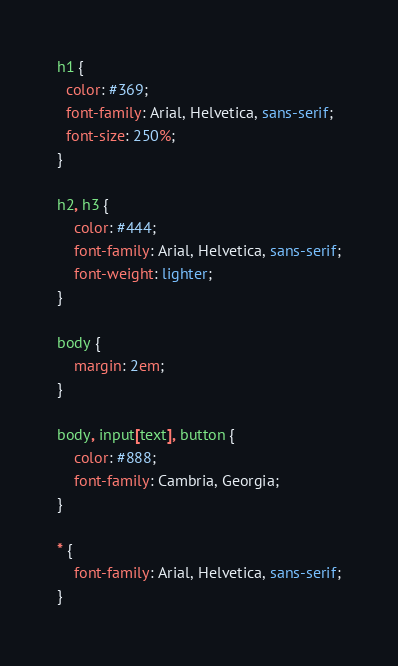<code> <loc_0><loc_0><loc_500><loc_500><_CSS_>h1 {
  color: #369;
  font-family: Arial, Helvetica, sans-serif;
  font-size: 250%;
}

h2, h3 {
	color: #444;
	font-family: Arial, Helvetica, sans-serif;
	font-weight: lighter;
}

body {
	margin: 2em;
}

body, input[text], button {
	color: #888;
	font-family: Cambria, Georgia;
}

* {
	font-family: Arial, Helvetica, sans-serif;
}
</code> 